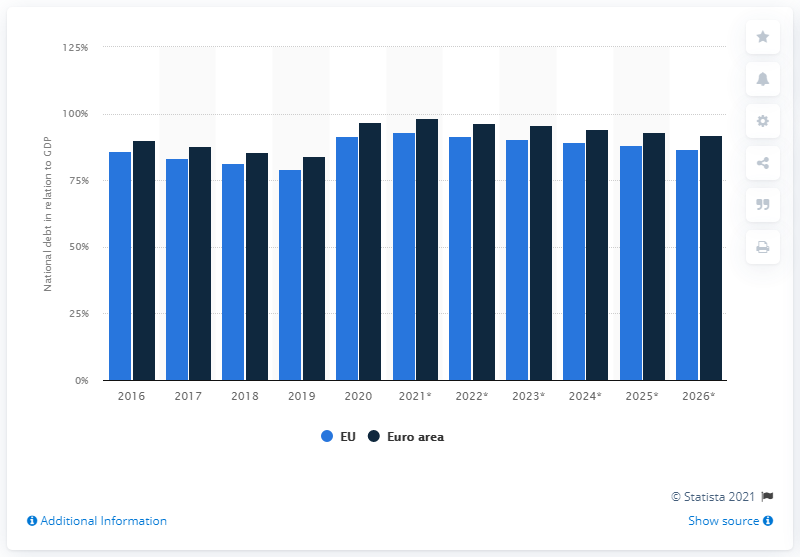List a handful of essential elements in this visual. In 2020, the national debt of the European Union and the euro area came to an end. 